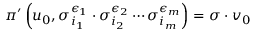Convert formula to latex. <formula><loc_0><loc_0><loc_500><loc_500>\pi ^ { \prime } \left ( u _ { 0 } , \sigma _ { i _ { 1 } } ^ { \epsilon _ { 1 } } \cdot \sigma _ { i _ { 2 } } ^ { \epsilon _ { 2 } } \cdots \sigma _ { i _ { m } } ^ { \epsilon _ { m } } \right ) = \sigma \cdot v _ { 0 }</formula> 